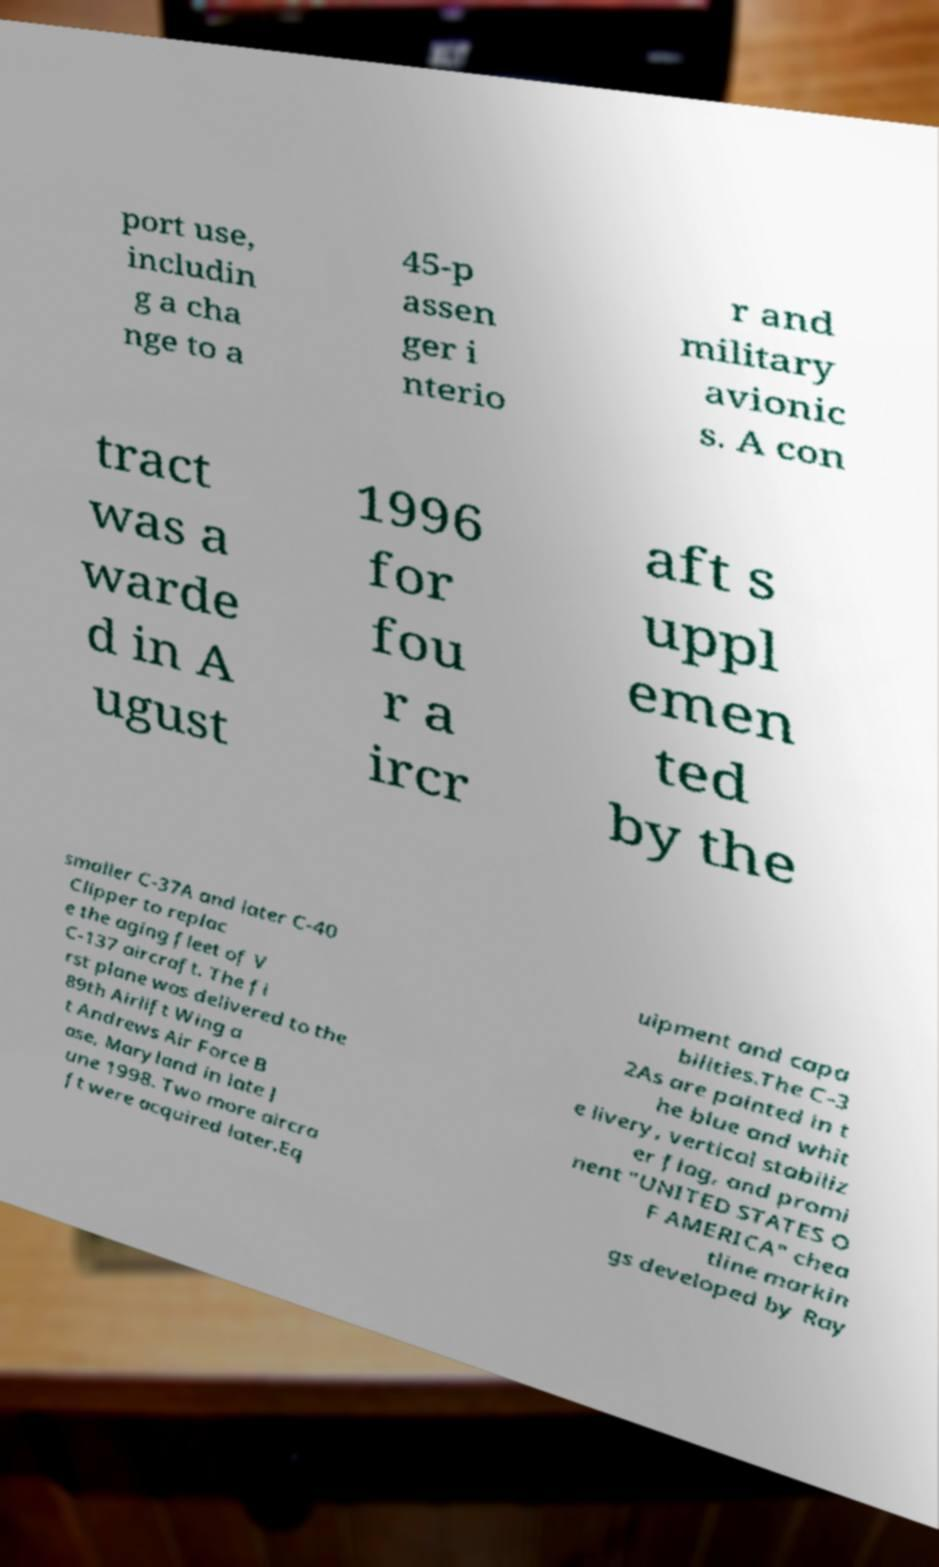Could you assist in decoding the text presented in this image and type it out clearly? port use, includin g a cha nge to a 45-p assen ger i nterio r and military avionic s. A con tract was a warde d in A ugust 1996 for fou r a ircr aft s uppl emen ted by the smaller C-37A and later C-40 Clipper to replac e the aging fleet of V C-137 aircraft. The fi rst plane was delivered to the 89th Airlift Wing a t Andrews Air Force B ase, Maryland in late J une 1998. Two more aircra ft were acquired later.Eq uipment and capa bilities.The C-3 2As are painted in t he blue and whit e livery, vertical stabiliz er flag, and promi nent "UNITED STATES O F AMERICA" chea tline markin gs developed by Ray 